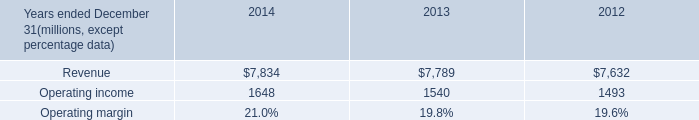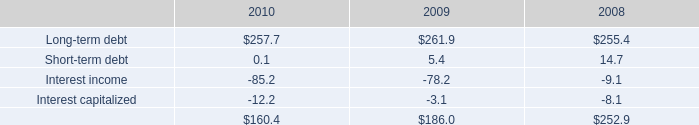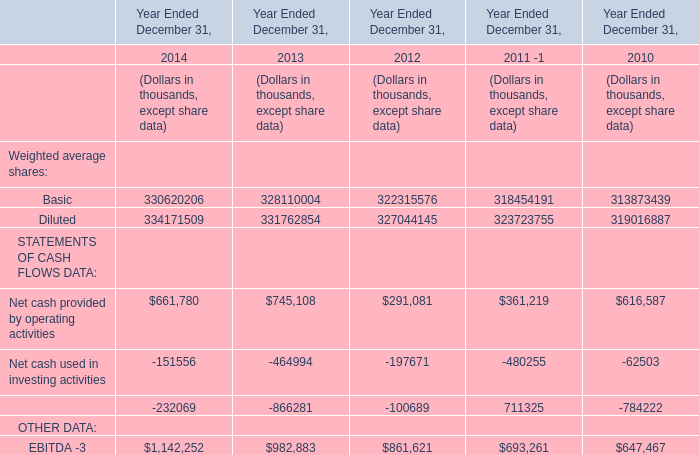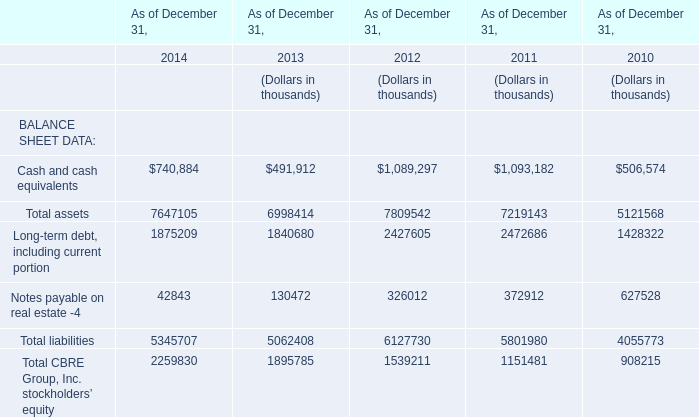what is the growth rate of revenue from 2013 to 2014? 
Computations: ((7834 - 7789) / 7789)
Answer: 0.00578. 